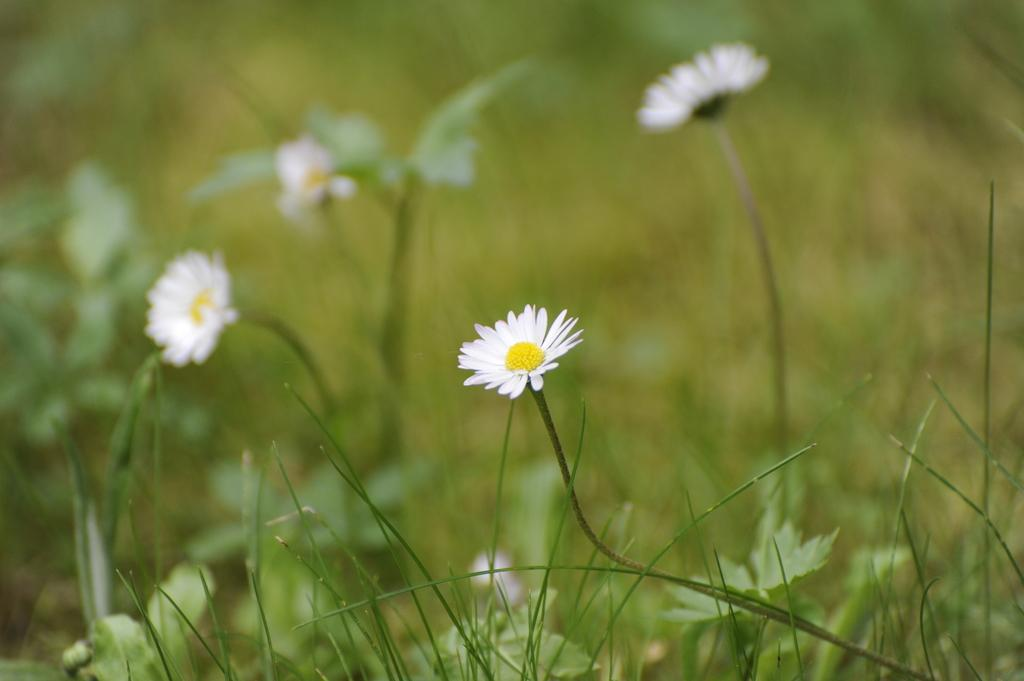What type of plants can be seen in the image? There are white color flower plants in the image. Where are the flower plants located? The flower plants are on a grass field. What type of skirt is the bear wearing in the image? There is no bear or skirt present in the image. 